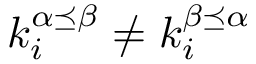Convert formula to latex. <formula><loc_0><loc_0><loc_500><loc_500>k _ { i } ^ { \alpha \preceq \beta } \neq k _ { i } ^ { \beta \preceq \alpha }</formula> 